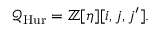Convert formula to latex. <formula><loc_0><loc_0><loc_500><loc_500>{ \mathcal { Q } } _ { H u r } = \mathbb { Z } [ \eta ] [ i , j , j ^ { \prime } ] .</formula> 